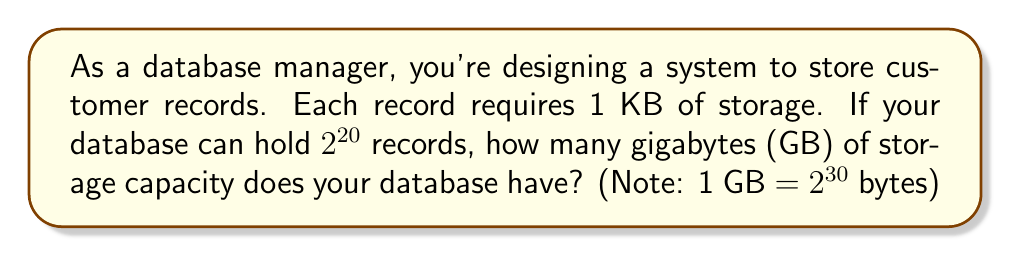Give your solution to this math problem. Let's approach this step-by-step:

1) First, we need to calculate the total number of bytes our database can hold:
   - Each record is 1 KB = $2^{10}$ bytes
   - We can store $2^{20}$ records
   - Total bytes = $2^{20} \times 2^{10} = 2^{30}$ bytes

2) Now, we need to convert this to gigabytes:
   - We're given that 1 GB = $2^{30}$ bytes
   - Our database capacity in bytes is exactly $2^{30}$ bytes

3) Therefore, our database capacity in GB is:
   $$ \frac{2^{30} \text{ bytes}}{2^{30} \text{ bytes/GB}} = 1 \text{ GB} $$

This problem demonstrates how exponents can be used to represent and calculate large amounts of data storage efficiently, which is crucial in database management.
Answer: 1 GB 